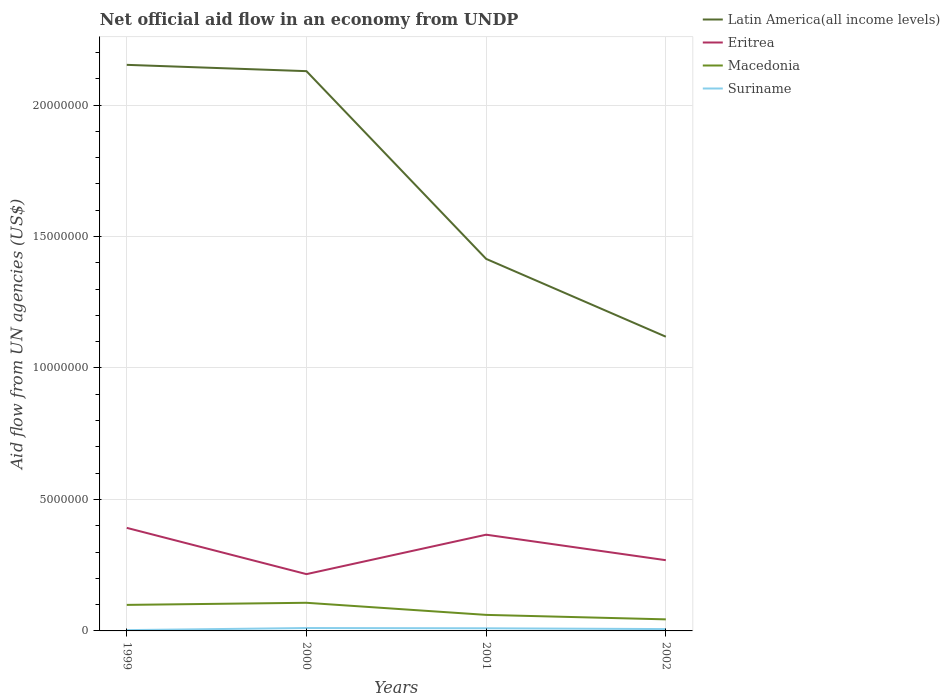How many different coloured lines are there?
Your answer should be very brief. 4. Does the line corresponding to Macedonia intersect with the line corresponding to Eritrea?
Provide a succinct answer. No. Across all years, what is the maximum net official aid flow in Latin America(all income levels)?
Your response must be concise. 1.12e+07. What is the total net official aid flow in Eritrea in the graph?
Provide a succinct answer. 9.70e+05. What is the difference between the highest and the second highest net official aid flow in Latin America(all income levels)?
Make the answer very short. 1.03e+07. How many years are there in the graph?
Offer a very short reply. 4. What is the difference between two consecutive major ticks on the Y-axis?
Provide a short and direct response. 5.00e+06. Does the graph contain any zero values?
Your response must be concise. No. Does the graph contain grids?
Provide a succinct answer. Yes. What is the title of the graph?
Ensure brevity in your answer.  Net official aid flow in an economy from UNDP. Does "Andorra" appear as one of the legend labels in the graph?
Offer a terse response. No. What is the label or title of the Y-axis?
Your answer should be very brief. Aid flow from UN agencies (US$). What is the Aid flow from UN agencies (US$) in Latin America(all income levels) in 1999?
Give a very brief answer. 2.15e+07. What is the Aid flow from UN agencies (US$) of Eritrea in 1999?
Your response must be concise. 3.92e+06. What is the Aid flow from UN agencies (US$) of Macedonia in 1999?
Provide a short and direct response. 9.90e+05. What is the Aid flow from UN agencies (US$) of Latin America(all income levels) in 2000?
Make the answer very short. 2.13e+07. What is the Aid flow from UN agencies (US$) in Eritrea in 2000?
Give a very brief answer. 2.16e+06. What is the Aid flow from UN agencies (US$) of Macedonia in 2000?
Provide a short and direct response. 1.07e+06. What is the Aid flow from UN agencies (US$) of Suriname in 2000?
Give a very brief answer. 1.10e+05. What is the Aid flow from UN agencies (US$) of Latin America(all income levels) in 2001?
Offer a terse response. 1.42e+07. What is the Aid flow from UN agencies (US$) of Eritrea in 2001?
Provide a succinct answer. 3.66e+06. What is the Aid flow from UN agencies (US$) of Macedonia in 2001?
Ensure brevity in your answer.  6.10e+05. What is the Aid flow from UN agencies (US$) of Suriname in 2001?
Give a very brief answer. 1.00e+05. What is the Aid flow from UN agencies (US$) in Latin America(all income levels) in 2002?
Provide a short and direct response. 1.12e+07. What is the Aid flow from UN agencies (US$) in Eritrea in 2002?
Your answer should be compact. 2.69e+06. What is the Aid flow from UN agencies (US$) in Macedonia in 2002?
Provide a succinct answer. 4.40e+05. What is the Aid flow from UN agencies (US$) in Suriname in 2002?
Keep it short and to the point. 7.00e+04. Across all years, what is the maximum Aid flow from UN agencies (US$) of Latin America(all income levels)?
Your answer should be compact. 2.15e+07. Across all years, what is the maximum Aid flow from UN agencies (US$) of Eritrea?
Offer a very short reply. 3.92e+06. Across all years, what is the maximum Aid flow from UN agencies (US$) in Macedonia?
Provide a succinct answer. 1.07e+06. Across all years, what is the maximum Aid flow from UN agencies (US$) in Suriname?
Offer a very short reply. 1.10e+05. Across all years, what is the minimum Aid flow from UN agencies (US$) of Latin America(all income levels)?
Provide a succinct answer. 1.12e+07. Across all years, what is the minimum Aid flow from UN agencies (US$) of Eritrea?
Provide a short and direct response. 2.16e+06. Across all years, what is the minimum Aid flow from UN agencies (US$) in Suriname?
Provide a short and direct response. 3.00e+04. What is the total Aid flow from UN agencies (US$) in Latin America(all income levels) in the graph?
Your response must be concise. 6.82e+07. What is the total Aid flow from UN agencies (US$) of Eritrea in the graph?
Make the answer very short. 1.24e+07. What is the total Aid flow from UN agencies (US$) of Macedonia in the graph?
Ensure brevity in your answer.  3.11e+06. What is the difference between the Aid flow from UN agencies (US$) in Eritrea in 1999 and that in 2000?
Ensure brevity in your answer.  1.76e+06. What is the difference between the Aid flow from UN agencies (US$) of Macedonia in 1999 and that in 2000?
Keep it short and to the point. -8.00e+04. What is the difference between the Aid flow from UN agencies (US$) in Latin America(all income levels) in 1999 and that in 2001?
Offer a terse response. 7.38e+06. What is the difference between the Aid flow from UN agencies (US$) of Eritrea in 1999 and that in 2001?
Keep it short and to the point. 2.60e+05. What is the difference between the Aid flow from UN agencies (US$) in Latin America(all income levels) in 1999 and that in 2002?
Offer a very short reply. 1.03e+07. What is the difference between the Aid flow from UN agencies (US$) of Eritrea in 1999 and that in 2002?
Your answer should be compact. 1.23e+06. What is the difference between the Aid flow from UN agencies (US$) in Macedonia in 1999 and that in 2002?
Make the answer very short. 5.50e+05. What is the difference between the Aid flow from UN agencies (US$) in Latin America(all income levels) in 2000 and that in 2001?
Keep it short and to the point. 7.14e+06. What is the difference between the Aid flow from UN agencies (US$) of Eritrea in 2000 and that in 2001?
Ensure brevity in your answer.  -1.50e+06. What is the difference between the Aid flow from UN agencies (US$) of Suriname in 2000 and that in 2001?
Make the answer very short. 10000. What is the difference between the Aid flow from UN agencies (US$) in Latin America(all income levels) in 2000 and that in 2002?
Offer a very short reply. 1.01e+07. What is the difference between the Aid flow from UN agencies (US$) of Eritrea in 2000 and that in 2002?
Your response must be concise. -5.30e+05. What is the difference between the Aid flow from UN agencies (US$) of Macedonia in 2000 and that in 2002?
Ensure brevity in your answer.  6.30e+05. What is the difference between the Aid flow from UN agencies (US$) of Latin America(all income levels) in 2001 and that in 2002?
Offer a terse response. 2.96e+06. What is the difference between the Aid flow from UN agencies (US$) in Eritrea in 2001 and that in 2002?
Give a very brief answer. 9.70e+05. What is the difference between the Aid flow from UN agencies (US$) of Suriname in 2001 and that in 2002?
Provide a short and direct response. 3.00e+04. What is the difference between the Aid flow from UN agencies (US$) of Latin America(all income levels) in 1999 and the Aid flow from UN agencies (US$) of Eritrea in 2000?
Your response must be concise. 1.94e+07. What is the difference between the Aid flow from UN agencies (US$) of Latin America(all income levels) in 1999 and the Aid flow from UN agencies (US$) of Macedonia in 2000?
Keep it short and to the point. 2.05e+07. What is the difference between the Aid flow from UN agencies (US$) of Latin America(all income levels) in 1999 and the Aid flow from UN agencies (US$) of Suriname in 2000?
Give a very brief answer. 2.14e+07. What is the difference between the Aid flow from UN agencies (US$) in Eritrea in 1999 and the Aid flow from UN agencies (US$) in Macedonia in 2000?
Offer a terse response. 2.85e+06. What is the difference between the Aid flow from UN agencies (US$) in Eritrea in 1999 and the Aid flow from UN agencies (US$) in Suriname in 2000?
Provide a succinct answer. 3.81e+06. What is the difference between the Aid flow from UN agencies (US$) of Macedonia in 1999 and the Aid flow from UN agencies (US$) of Suriname in 2000?
Your response must be concise. 8.80e+05. What is the difference between the Aid flow from UN agencies (US$) in Latin America(all income levels) in 1999 and the Aid flow from UN agencies (US$) in Eritrea in 2001?
Keep it short and to the point. 1.79e+07. What is the difference between the Aid flow from UN agencies (US$) in Latin America(all income levels) in 1999 and the Aid flow from UN agencies (US$) in Macedonia in 2001?
Your response must be concise. 2.09e+07. What is the difference between the Aid flow from UN agencies (US$) of Latin America(all income levels) in 1999 and the Aid flow from UN agencies (US$) of Suriname in 2001?
Your answer should be compact. 2.14e+07. What is the difference between the Aid flow from UN agencies (US$) in Eritrea in 1999 and the Aid flow from UN agencies (US$) in Macedonia in 2001?
Your response must be concise. 3.31e+06. What is the difference between the Aid flow from UN agencies (US$) of Eritrea in 1999 and the Aid flow from UN agencies (US$) of Suriname in 2001?
Your answer should be very brief. 3.82e+06. What is the difference between the Aid flow from UN agencies (US$) of Macedonia in 1999 and the Aid flow from UN agencies (US$) of Suriname in 2001?
Offer a very short reply. 8.90e+05. What is the difference between the Aid flow from UN agencies (US$) in Latin America(all income levels) in 1999 and the Aid flow from UN agencies (US$) in Eritrea in 2002?
Offer a very short reply. 1.88e+07. What is the difference between the Aid flow from UN agencies (US$) in Latin America(all income levels) in 1999 and the Aid flow from UN agencies (US$) in Macedonia in 2002?
Your answer should be compact. 2.11e+07. What is the difference between the Aid flow from UN agencies (US$) of Latin America(all income levels) in 1999 and the Aid flow from UN agencies (US$) of Suriname in 2002?
Keep it short and to the point. 2.15e+07. What is the difference between the Aid flow from UN agencies (US$) in Eritrea in 1999 and the Aid flow from UN agencies (US$) in Macedonia in 2002?
Give a very brief answer. 3.48e+06. What is the difference between the Aid flow from UN agencies (US$) of Eritrea in 1999 and the Aid flow from UN agencies (US$) of Suriname in 2002?
Give a very brief answer. 3.85e+06. What is the difference between the Aid flow from UN agencies (US$) in Macedonia in 1999 and the Aid flow from UN agencies (US$) in Suriname in 2002?
Offer a very short reply. 9.20e+05. What is the difference between the Aid flow from UN agencies (US$) in Latin America(all income levels) in 2000 and the Aid flow from UN agencies (US$) in Eritrea in 2001?
Provide a succinct answer. 1.76e+07. What is the difference between the Aid flow from UN agencies (US$) in Latin America(all income levels) in 2000 and the Aid flow from UN agencies (US$) in Macedonia in 2001?
Make the answer very short. 2.07e+07. What is the difference between the Aid flow from UN agencies (US$) in Latin America(all income levels) in 2000 and the Aid flow from UN agencies (US$) in Suriname in 2001?
Your answer should be very brief. 2.12e+07. What is the difference between the Aid flow from UN agencies (US$) of Eritrea in 2000 and the Aid flow from UN agencies (US$) of Macedonia in 2001?
Make the answer very short. 1.55e+06. What is the difference between the Aid flow from UN agencies (US$) of Eritrea in 2000 and the Aid flow from UN agencies (US$) of Suriname in 2001?
Give a very brief answer. 2.06e+06. What is the difference between the Aid flow from UN agencies (US$) of Macedonia in 2000 and the Aid flow from UN agencies (US$) of Suriname in 2001?
Offer a very short reply. 9.70e+05. What is the difference between the Aid flow from UN agencies (US$) of Latin America(all income levels) in 2000 and the Aid flow from UN agencies (US$) of Eritrea in 2002?
Give a very brief answer. 1.86e+07. What is the difference between the Aid flow from UN agencies (US$) of Latin America(all income levels) in 2000 and the Aid flow from UN agencies (US$) of Macedonia in 2002?
Make the answer very short. 2.08e+07. What is the difference between the Aid flow from UN agencies (US$) of Latin America(all income levels) in 2000 and the Aid flow from UN agencies (US$) of Suriname in 2002?
Give a very brief answer. 2.12e+07. What is the difference between the Aid flow from UN agencies (US$) of Eritrea in 2000 and the Aid flow from UN agencies (US$) of Macedonia in 2002?
Provide a succinct answer. 1.72e+06. What is the difference between the Aid flow from UN agencies (US$) of Eritrea in 2000 and the Aid flow from UN agencies (US$) of Suriname in 2002?
Your answer should be very brief. 2.09e+06. What is the difference between the Aid flow from UN agencies (US$) in Latin America(all income levels) in 2001 and the Aid flow from UN agencies (US$) in Eritrea in 2002?
Make the answer very short. 1.15e+07. What is the difference between the Aid flow from UN agencies (US$) of Latin America(all income levels) in 2001 and the Aid flow from UN agencies (US$) of Macedonia in 2002?
Give a very brief answer. 1.37e+07. What is the difference between the Aid flow from UN agencies (US$) of Latin America(all income levels) in 2001 and the Aid flow from UN agencies (US$) of Suriname in 2002?
Make the answer very short. 1.41e+07. What is the difference between the Aid flow from UN agencies (US$) in Eritrea in 2001 and the Aid flow from UN agencies (US$) in Macedonia in 2002?
Offer a terse response. 3.22e+06. What is the difference between the Aid flow from UN agencies (US$) in Eritrea in 2001 and the Aid flow from UN agencies (US$) in Suriname in 2002?
Make the answer very short. 3.59e+06. What is the difference between the Aid flow from UN agencies (US$) in Macedonia in 2001 and the Aid flow from UN agencies (US$) in Suriname in 2002?
Offer a terse response. 5.40e+05. What is the average Aid flow from UN agencies (US$) of Latin America(all income levels) per year?
Keep it short and to the point. 1.70e+07. What is the average Aid flow from UN agencies (US$) of Eritrea per year?
Ensure brevity in your answer.  3.11e+06. What is the average Aid flow from UN agencies (US$) of Macedonia per year?
Your answer should be compact. 7.78e+05. What is the average Aid flow from UN agencies (US$) of Suriname per year?
Your answer should be compact. 7.75e+04. In the year 1999, what is the difference between the Aid flow from UN agencies (US$) of Latin America(all income levels) and Aid flow from UN agencies (US$) of Eritrea?
Keep it short and to the point. 1.76e+07. In the year 1999, what is the difference between the Aid flow from UN agencies (US$) in Latin America(all income levels) and Aid flow from UN agencies (US$) in Macedonia?
Offer a terse response. 2.05e+07. In the year 1999, what is the difference between the Aid flow from UN agencies (US$) of Latin America(all income levels) and Aid flow from UN agencies (US$) of Suriname?
Offer a very short reply. 2.15e+07. In the year 1999, what is the difference between the Aid flow from UN agencies (US$) in Eritrea and Aid flow from UN agencies (US$) in Macedonia?
Your response must be concise. 2.93e+06. In the year 1999, what is the difference between the Aid flow from UN agencies (US$) in Eritrea and Aid flow from UN agencies (US$) in Suriname?
Offer a terse response. 3.89e+06. In the year 1999, what is the difference between the Aid flow from UN agencies (US$) of Macedonia and Aid flow from UN agencies (US$) of Suriname?
Provide a short and direct response. 9.60e+05. In the year 2000, what is the difference between the Aid flow from UN agencies (US$) of Latin America(all income levels) and Aid flow from UN agencies (US$) of Eritrea?
Give a very brief answer. 1.91e+07. In the year 2000, what is the difference between the Aid flow from UN agencies (US$) in Latin America(all income levels) and Aid flow from UN agencies (US$) in Macedonia?
Offer a terse response. 2.02e+07. In the year 2000, what is the difference between the Aid flow from UN agencies (US$) in Latin America(all income levels) and Aid flow from UN agencies (US$) in Suriname?
Make the answer very short. 2.12e+07. In the year 2000, what is the difference between the Aid flow from UN agencies (US$) of Eritrea and Aid flow from UN agencies (US$) of Macedonia?
Make the answer very short. 1.09e+06. In the year 2000, what is the difference between the Aid flow from UN agencies (US$) in Eritrea and Aid flow from UN agencies (US$) in Suriname?
Make the answer very short. 2.05e+06. In the year 2000, what is the difference between the Aid flow from UN agencies (US$) of Macedonia and Aid flow from UN agencies (US$) of Suriname?
Your answer should be compact. 9.60e+05. In the year 2001, what is the difference between the Aid flow from UN agencies (US$) of Latin America(all income levels) and Aid flow from UN agencies (US$) of Eritrea?
Make the answer very short. 1.05e+07. In the year 2001, what is the difference between the Aid flow from UN agencies (US$) in Latin America(all income levels) and Aid flow from UN agencies (US$) in Macedonia?
Ensure brevity in your answer.  1.35e+07. In the year 2001, what is the difference between the Aid flow from UN agencies (US$) in Latin America(all income levels) and Aid flow from UN agencies (US$) in Suriname?
Your answer should be compact. 1.40e+07. In the year 2001, what is the difference between the Aid flow from UN agencies (US$) of Eritrea and Aid flow from UN agencies (US$) of Macedonia?
Offer a very short reply. 3.05e+06. In the year 2001, what is the difference between the Aid flow from UN agencies (US$) in Eritrea and Aid flow from UN agencies (US$) in Suriname?
Give a very brief answer. 3.56e+06. In the year 2001, what is the difference between the Aid flow from UN agencies (US$) of Macedonia and Aid flow from UN agencies (US$) of Suriname?
Provide a succinct answer. 5.10e+05. In the year 2002, what is the difference between the Aid flow from UN agencies (US$) of Latin America(all income levels) and Aid flow from UN agencies (US$) of Eritrea?
Offer a very short reply. 8.50e+06. In the year 2002, what is the difference between the Aid flow from UN agencies (US$) of Latin America(all income levels) and Aid flow from UN agencies (US$) of Macedonia?
Offer a very short reply. 1.08e+07. In the year 2002, what is the difference between the Aid flow from UN agencies (US$) of Latin America(all income levels) and Aid flow from UN agencies (US$) of Suriname?
Your response must be concise. 1.11e+07. In the year 2002, what is the difference between the Aid flow from UN agencies (US$) of Eritrea and Aid flow from UN agencies (US$) of Macedonia?
Provide a short and direct response. 2.25e+06. In the year 2002, what is the difference between the Aid flow from UN agencies (US$) of Eritrea and Aid flow from UN agencies (US$) of Suriname?
Provide a short and direct response. 2.62e+06. In the year 2002, what is the difference between the Aid flow from UN agencies (US$) in Macedonia and Aid flow from UN agencies (US$) in Suriname?
Your answer should be compact. 3.70e+05. What is the ratio of the Aid flow from UN agencies (US$) in Latin America(all income levels) in 1999 to that in 2000?
Provide a short and direct response. 1.01. What is the ratio of the Aid flow from UN agencies (US$) of Eritrea in 1999 to that in 2000?
Offer a very short reply. 1.81. What is the ratio of the Aid flow from UN agencies (US$) in Macedonia in 1999 to that in 2000?
Keep it short and to the point. 0.93. What is the ratio of the Aid flow from UN agencies (US$) of Suriname in 1999 to that in 2000?
Ensure brevity in your answer.  0.27. What is the ratio of the Aid flow from UN agencies (US$) of Latin America(all income levels) in 1999 to that in 2001?
Your answer should be compact. 1.52. What is the ratio of the Aid flow from UN agencies (US$) of Eritrea in 1999 to that in 2001?
Keep it short and to the point. 1.07. What is the ratio of the Aid flow from UN agencies (US$) of Macedonia in 1999 to that in 2001?
Give a very brief answer. 1.62. What is the ratio of the Aid flow from UN agencies (US$) of Latin America(all income levels) in 1999 to that in 2002?
Give a very brief answer. 1.92. What is the ratio of the Aid flow from UN agencies (US$) in Eritrea in 1999 to that in 2002?
Give a very brief answer. 1.46. What is the ratio of the Aid flow from UN agencies (US$) of Macedonia in 1999 to that in 2002?
Your answer should be compact. 2.25. What is the ratio of the Aid flow from UN agencies (US$) of Suriname in 1999 to that in 2002?
Offer a very short reply. 0.43. What is the ratio of the Aid flow from UN agencies (US$) of Latin America(all income levels) in 2000 to that in 2001?
Provide a succinct answer. 1.5. What is the ratio of the Aid flow from UN agencies (US$) in Eritrea in 2000 to that in 2001?
Your answer should be compact. 0.59. What is the ratio of the Aid flow from UN agencies (US$) in Macedonia in 2000 to that in 2001?
Your answer should be compact. 1.75. What is the ratio of the Aid flow from UN agencies (US$) in Suriname in 2000 to that in 2001?
Your response must be concise. 1.1. What is the ratio of the Aid flow from UN agencies (US$) in Latin America(all income levels) in 2000 to that in 2002?
Make the answer very short. 1.9. What is the ratio of the Aid flow from UN agencies (US$) of Eritrea in 2000 to that in 2002?
Keep it short and to the point. 0.8. What is the ratio of the Aid flow from UN agencies (US$) in Macedonia in 2000 to that in 2002?
Ensure brevity in your answer.  2.43. What is the ratio of the Aid flow from UN agencies (US$) in Suriname in 2000 to that in 2002?
Keep it short and to the point. 1.57. What is the ratio of the Aid flow from UN agencies (US$) of Latin America(all income levels) in 2001 to that in 2002?
Provide a short and direct response. 1.26. What is the ratio of the Aid flow from UN agencies (US$) of Eritrea in 2001 to that in 2002?
Offer a very short reply. 1.36. What is the ratio of the Aid flow from UN agencies (US$) of Macedonia in 2001 to that in 2002?
Provide a short and direct response. 1.39. What is the ratio of the Aid flow from UN agencies (US$) of Suriname in 2001 to that in 2002?
Provide a succinct answer. 1.43. What is the difference between the highest and the second highest Aid flow from UN agencies (US$) of Suriname?
Your response must be concise. 10000. What is the difference between the highest and the lowest Aid flow from UN agencies (US$) of Latin America(all income levels)?
Make the answer very short. 1.03e+07. What is the difference between the highest and the lowest Aid flow from UN agencies (US$) in Eritrea?
Offer a terse response. 1.76e+06. What is the difference between the highest and the lowest Aid flow from UN agencies (US$) of Macedonia?
Offer a terse response. 6.30e+05. What is the difference between the highest and the lowest Aid flow from UN agencies (US$) of Suriname?
Keep it short and to the point. 8.00e+04. 